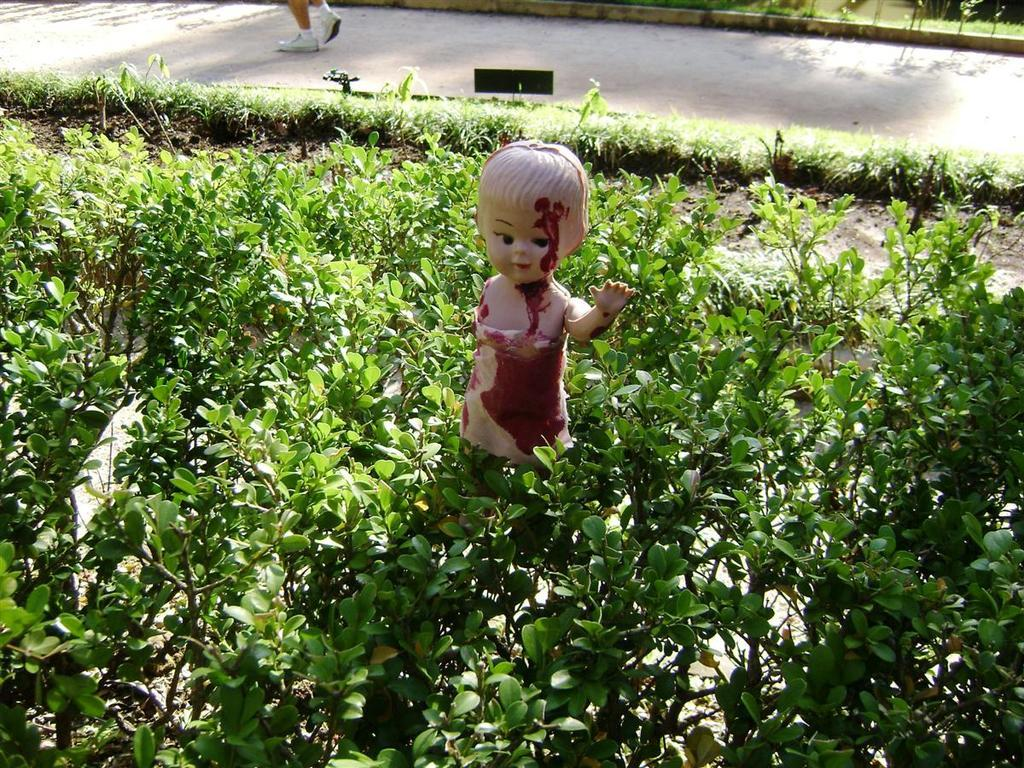What type of living organisms can be seen in the image? Plants can be seen in the image. What other object is present among the plants? There is a toy among the plants. What can be seen in the distance in the image? There is a road in the background of the image. Is there anyone visible near the road in the background? Yes, there is a person standing on the road in the background. What scientific experiment is being conducted in the image? There is no scientific experiment being conducted in the image. What type of yard is visible in the image? The image does not show a yard; it features plants, a toy, a road, and a person standing on the road. 